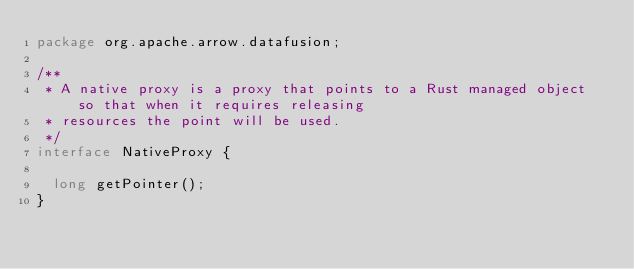<code> <loc_0><loc_0><loc_500><loc_500><_Java_>package org.apache.arrow.datafusion;

/**
 * A native proxy is a proxy that points to a Rust managed object so that when it requires releasing
 * resources the point will be used.
 */
interface NativeProxy {

  long getPointer();
}
</code> 